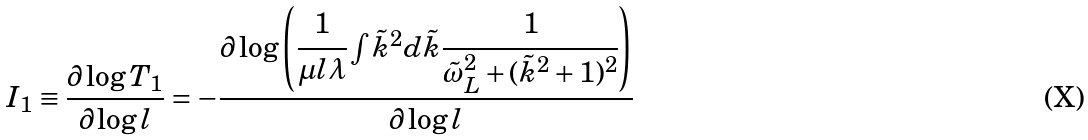Convert formula to latex. <formula><loc_0><loc_0><loc_500><loc_500>I _ { 1 } \equiv \frac { \partial \log T _ { 1 } } { \partial \log l } = - \cfrac { \partial \log \left ( \cfrac { 1 } { \mu l \lambda } \int \tilde { k } ^ { 2 } d \tilde { k } \cfrac { 1 } { \tilde { \omega } _ { L } ^ { 2 } + ( \tilde { k } ^ { 2 } + 1 ) ^ { 2 } } \right ) } { \partial \log l }</formula> 